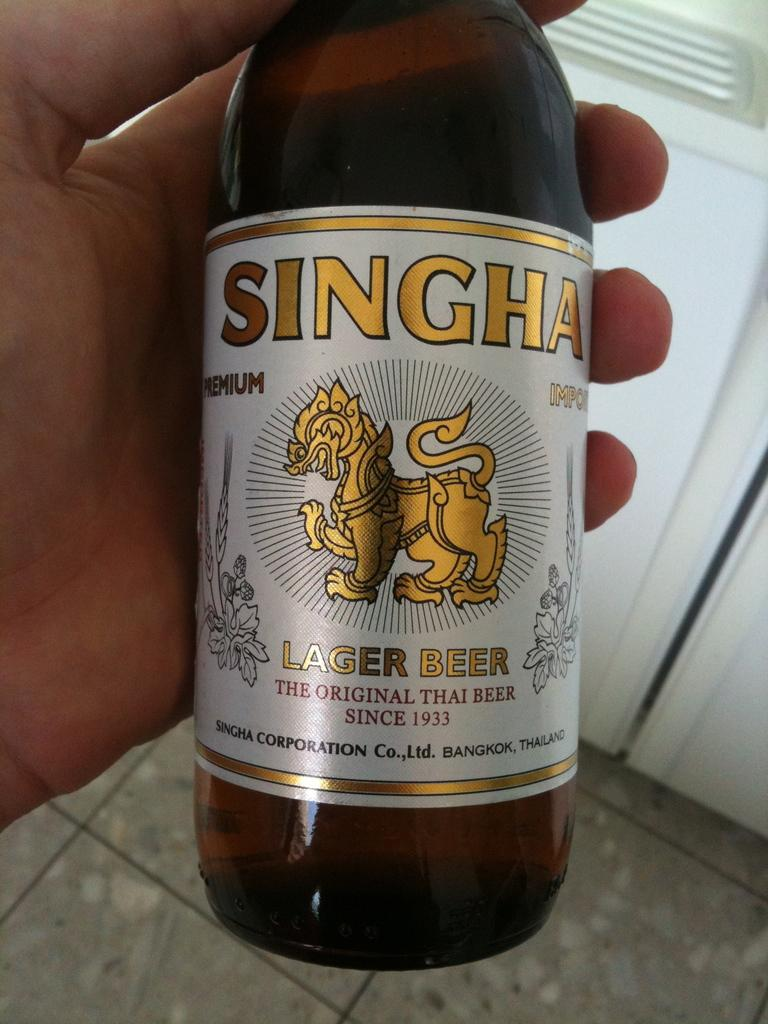<image>
Describe the image concisely. A bottle of lager beer called singha it has been around since 1933. 